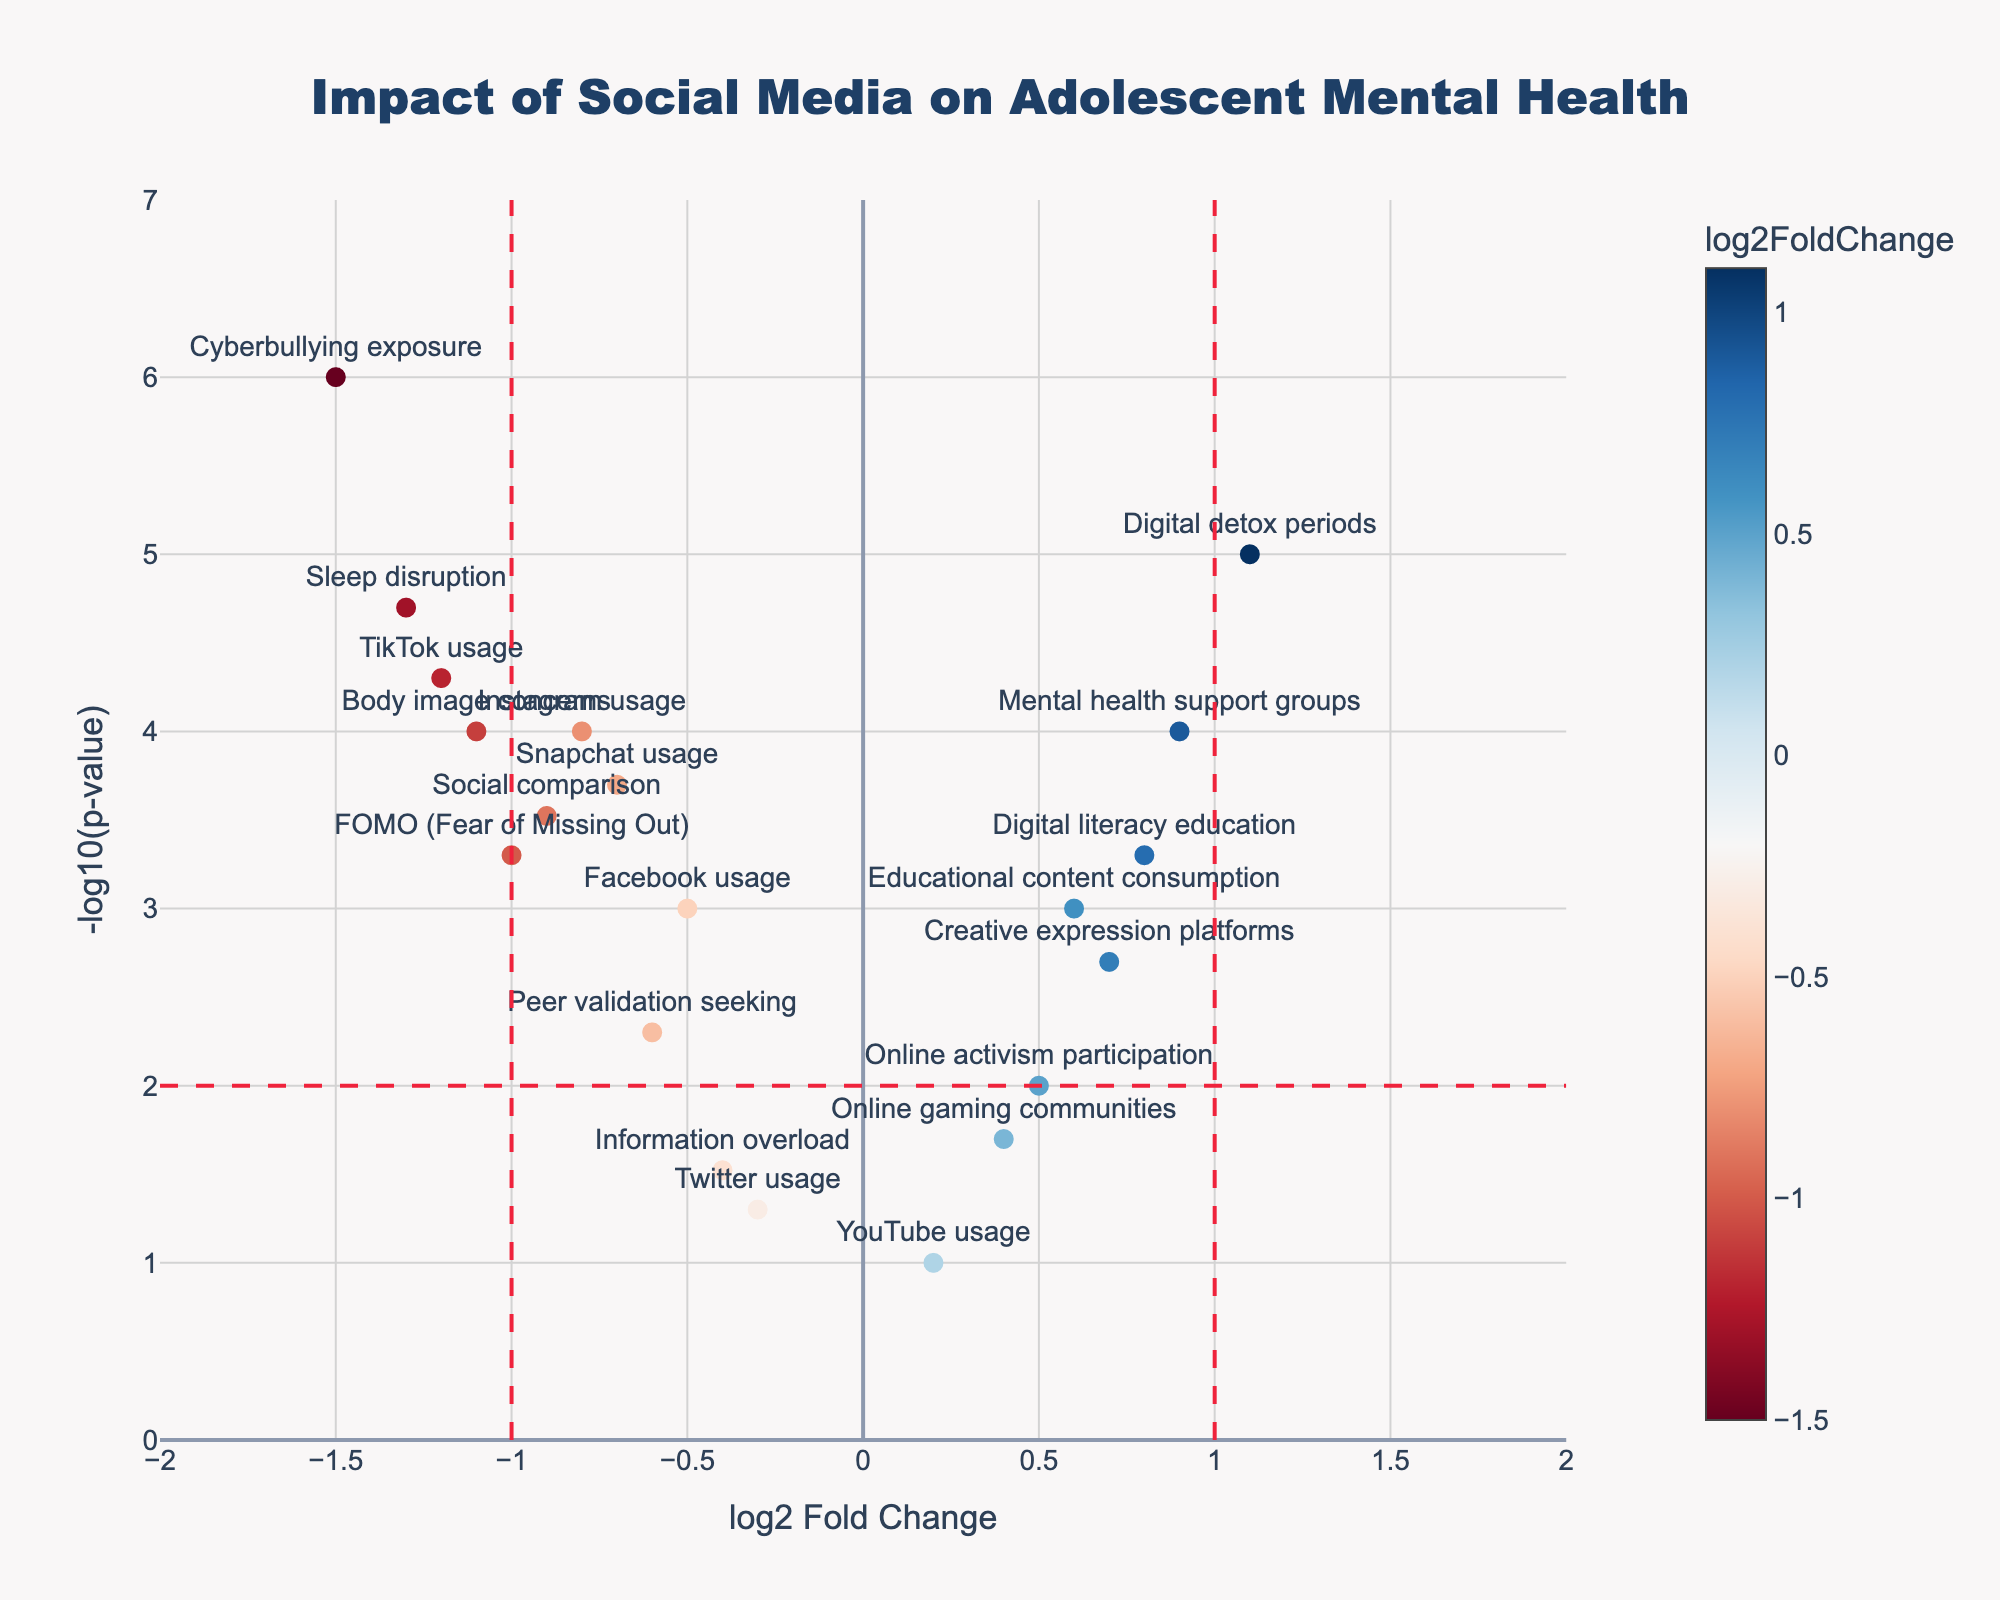How many data points indicate a log2 Fold Change greater than 1 or less than -1? Look for points beyond the thresholds of 1 and -1 on the x-axis. These thresholds are indicated by vertical dashed lines. Count the number of points to the right of the 1 line and to the left of the -1 line.
Answer: 5 Which usage factor has the most negative log2 Fold Change, and what is its p-value? Identify the point furthest to the left on the x-axis, representing the most negative log2 Fold Change. Check its corresponding p-value.
Answer: Cyberbullying exposure, 0.000001 What is the log2 Fold Change and p-value for Mental health support groups? Find the point labeled "Mental health support groups" and note its x (log2 Fold Change) and y (-log10(p-value)) coordinates.
Answer: 0.9, 0.0001 How many data points have a -log10(p-value) greater than 4? Count the number of points above the y-axis value of 4, as indicated by the y-axis ticks.
Answer: 4 Compare Instagram usage and YouTube usage in terms of log2 Fold Change and -log10(p-value). Which one shows higher statistical significance? Look at the specific points for "Instagram usage" and "YouTube usage." Compare their x and y values, noting which has a higher y-value (-log10(p-value)), indicating higher statistical significance.
Answer: Instagram usage: higher significance Which factors indicate a statistically significant positive impact on adolescent mental health? Look for points with a positive log2 Fold Change (right side of the x-axis) and a -log10(p-value) greater than 2 (above the horizontal dashed line).
Answer: Mental health support groups, Educational content consumption, Digital detox periods, Creative expression platforms, Digital literacy education What is the p-value of TikTok usage, and what does its log2 Fold Change suggest about its impact on mental health? Locate the "TikTok usage" point, note the corresponding y-value for -log10(p-value) to find its p-value and look at the x-value for log2 Fold Change to understand the impact.
Answer: 0.00005; suggests a negative impact Considering all points with a p-value less than 0.01, which has the least impact (log2 Fold Change closest to 0)? Filter data points with a -log10(p-value) greater than 2. Look for the point closest to the x-axis value of 0.
Answer: Facebook usage 